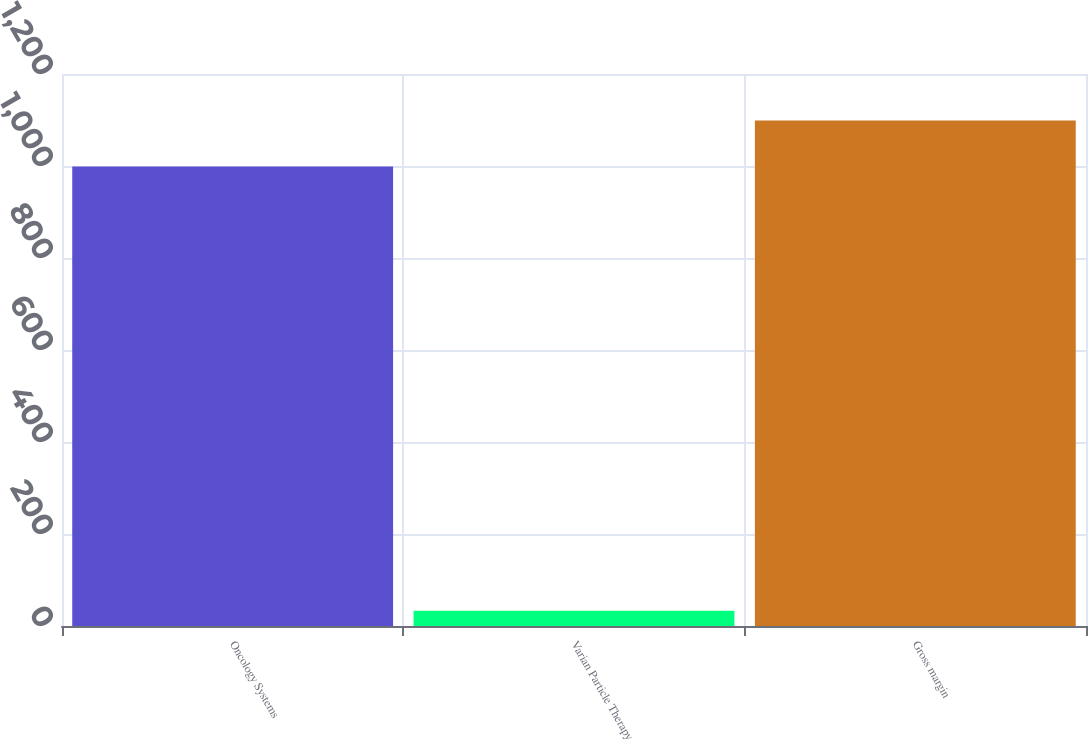<chart> <loc_0><loc_0><loc_500><loc_500><bar_chart><fcel>Oncology Systems<fcel>Varian Particle Therapy<fcel>Gross margin<nl><fcel>998.9<fcel>33.2<fcel>1098.79<nl></chart> 